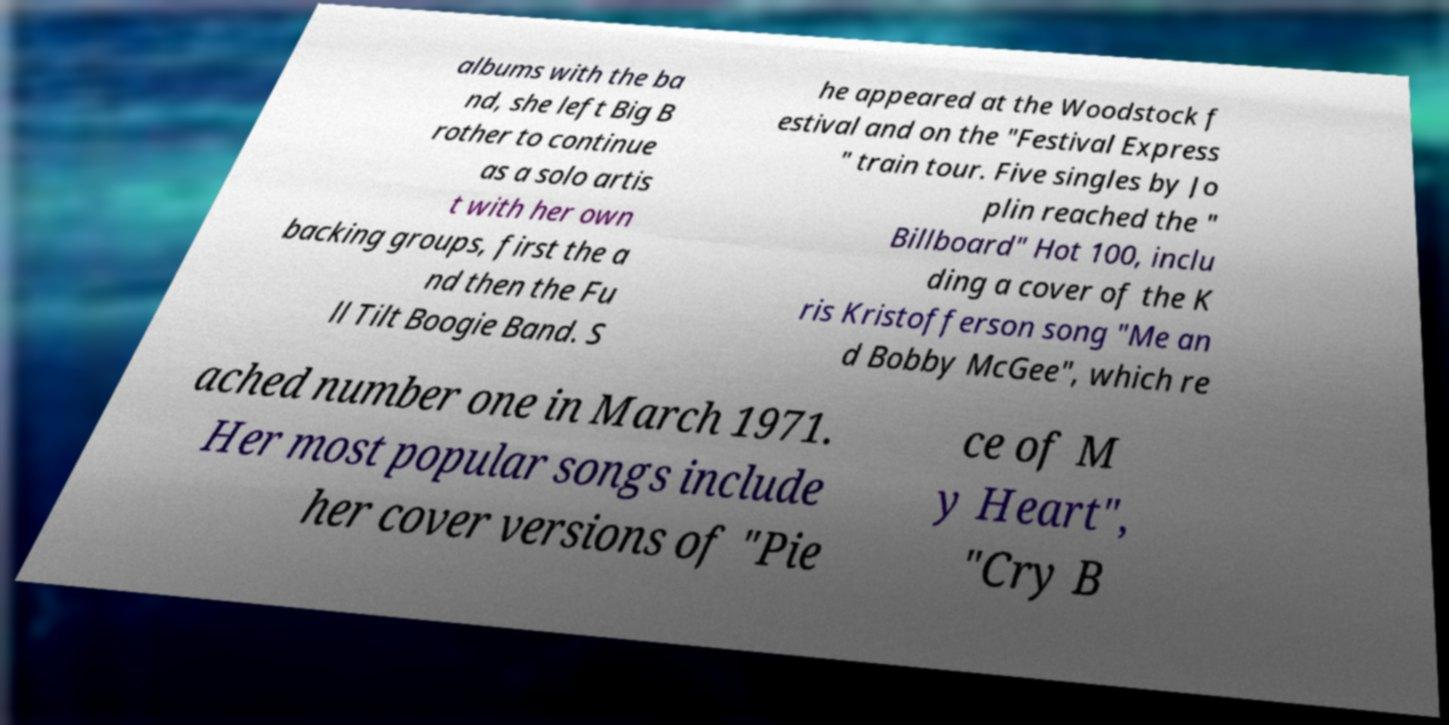For documentation purposes, I need the text within this image transcribed. Could you provide that? albums with the ba nd, she left Big B rother to continue as a solo artis t with her own backing groups, first the a nd then the Fu ll Tilt Boogie Band. S he appeared at the Woodstock f estival and on the "Festival Express " train tour. Five singles by Jo plin reached the " Billboard" Hot 100, inclu ding a cover of the K ris Kristofferson song "Me an d Bobby McGee", which re ached number one in March 1971. Her most popular songs include her cover versions of "Pie ce of M y Heart", "Cry B 